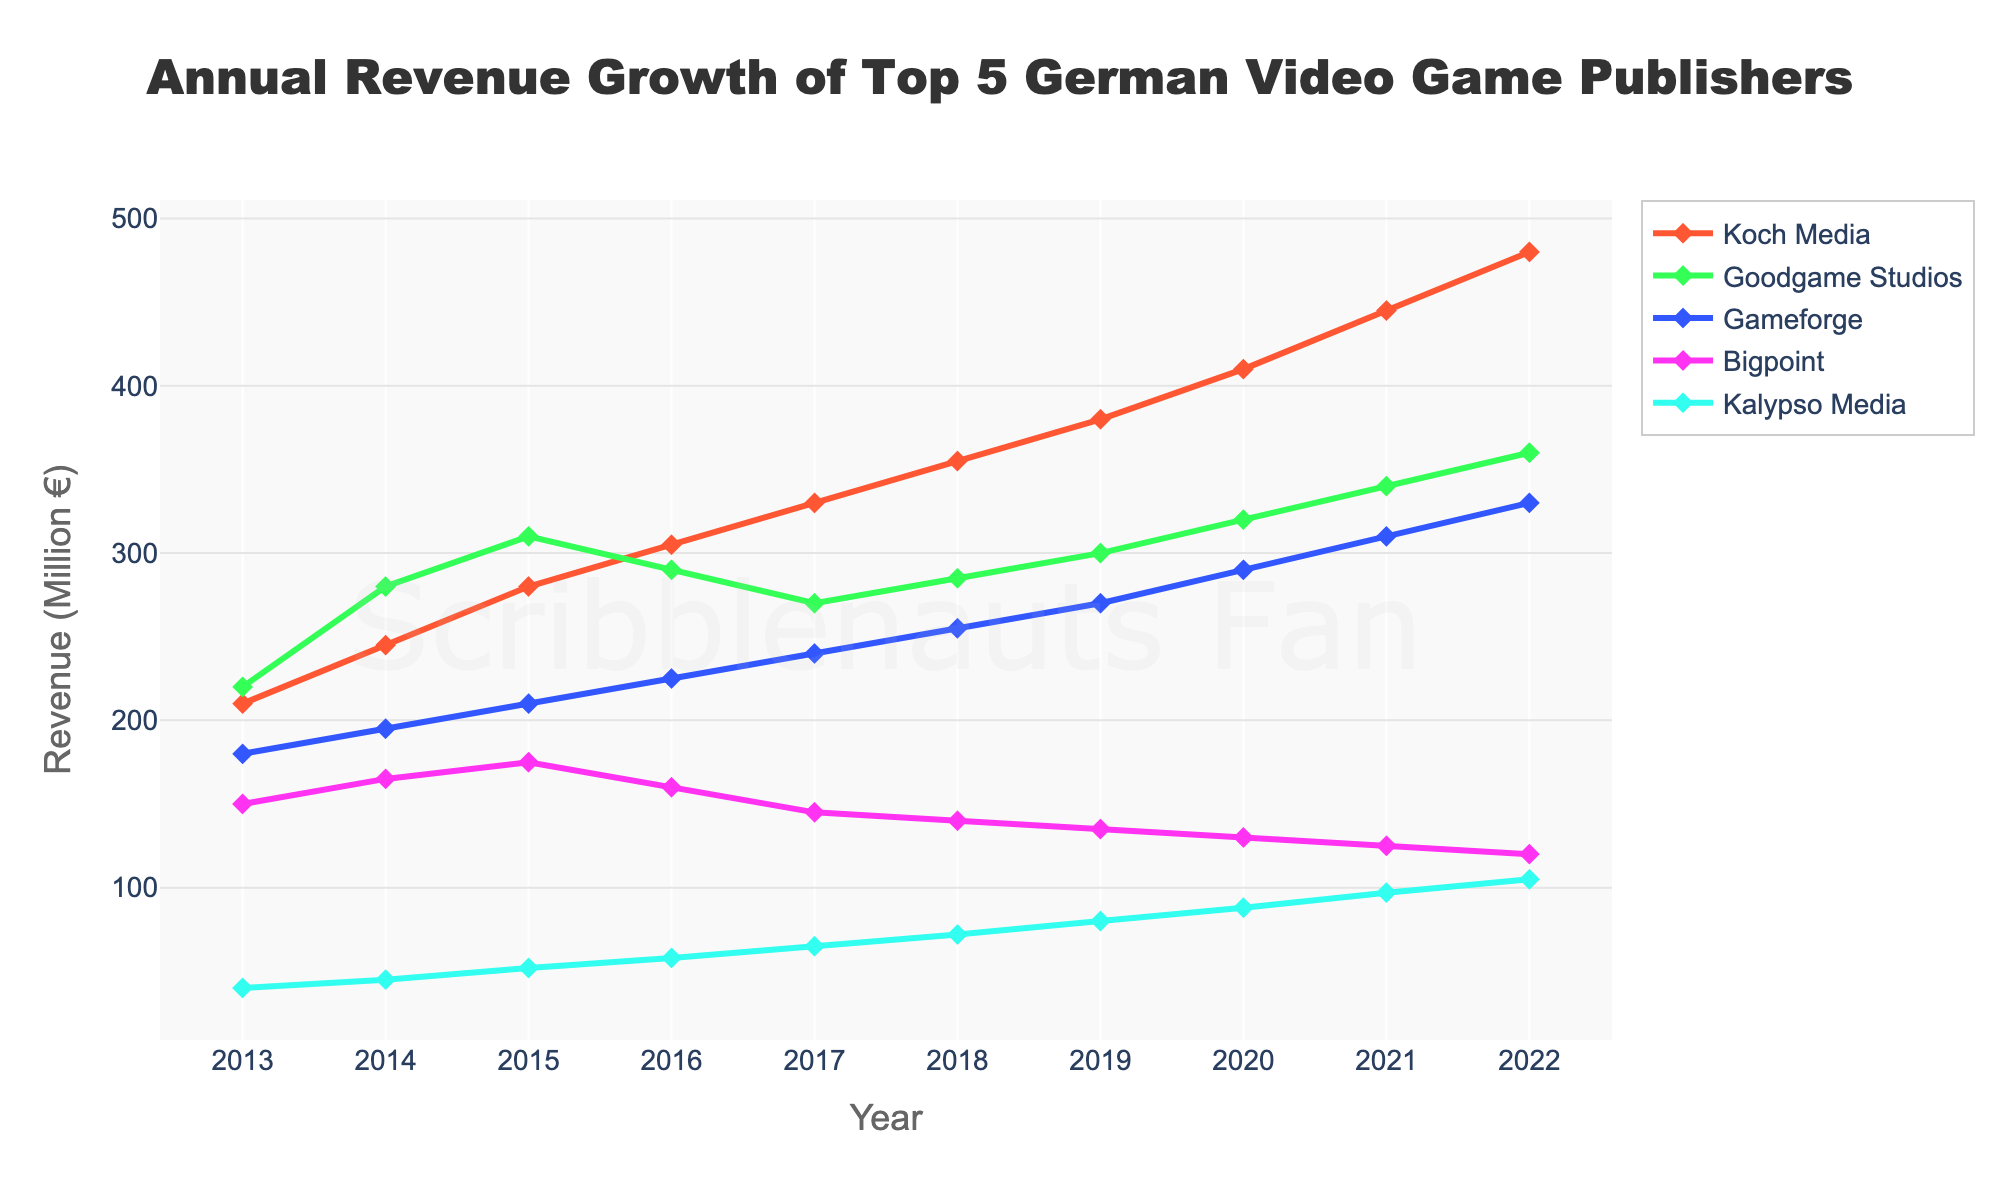What year did Koch Media overtake Goodgame Studios in terms of revenue? By analyzing the lines for Koch Media (red) and Goodgame Studios (green), we see that Koch Media overtakes Goodgame Studios around the year 2016.
Answer: 2016 Which publisher had the lowest revenue in 2013, and what was it? Observing the starting points of the lines in 2013, Kalypso Media (blue) had the lowest revenue at approximately 40 million €.
Answer: Kalypso Media, 40 million € Did any publisher’s revenue decline over the decade, and if so, which one? Analyzing the trends, every publisher shows growth over the years, so no publisher’s revenue declined.
Answer: None What was the revenue difference between Bigpoint and Gameforge in 2022? In 2022, Bigpoint had around 120 million €, and Gameforge had around 330 million €. The difference is 330 - 120 = 210 million €.
Answer: 210 million € Which publisher has shown the most consistent revenue growth? Koch Media (red) shows a clear and consistent upward trend without major fluctuations, indicating the most consistent growth.
Answer: Koch Media How much did Kalypso Media’s revenue grow from 2013 to 2022? Kalypso Media’s revenue in 2013 was approximately 40 million €, and in 2022 it was approximately 105 million €. The growth is 105 - 40 = 65 million €.
Answer: 65 million € In what year did Gameforge first surpass a revenue of 300 million €? Observing the purple line for Gameforge, it surpasses 300 million € around the year 2021.
Answer: 2021 Compare the revenue growth of Goodgame Studios and Kalypso Media between 2015 and 2020. Between 2015 and 2020, Goodgame Studios’ growth went from 310 million € to 320 million €, an increase of 10 million €. Kalypso Media’s growth went from 52 million € to 88 million €, an increase of 36 million €.
Answer: Goodgame: 10 million €, Kalypso: 36 million € What is the average revenue of Bigpoint over the decade? Adding Bigpoint's revenues from 2013 to 2022: 150 + 165 + 175 + 160 + 145 + 140 + 135 + 130 + 125 + 120 = 1445 million €. Dividing by 10 gives an average: 1445 ÷ 10 = 144.5 million €.
Answer: 144.5 million € Which publisher had the highest revenue in 2020, and how much was it? In 2020, the highest point on the chart corresponds to Koch Media, with a revenue of about 410 million €.
Answer: Koch Media, 410 million € 